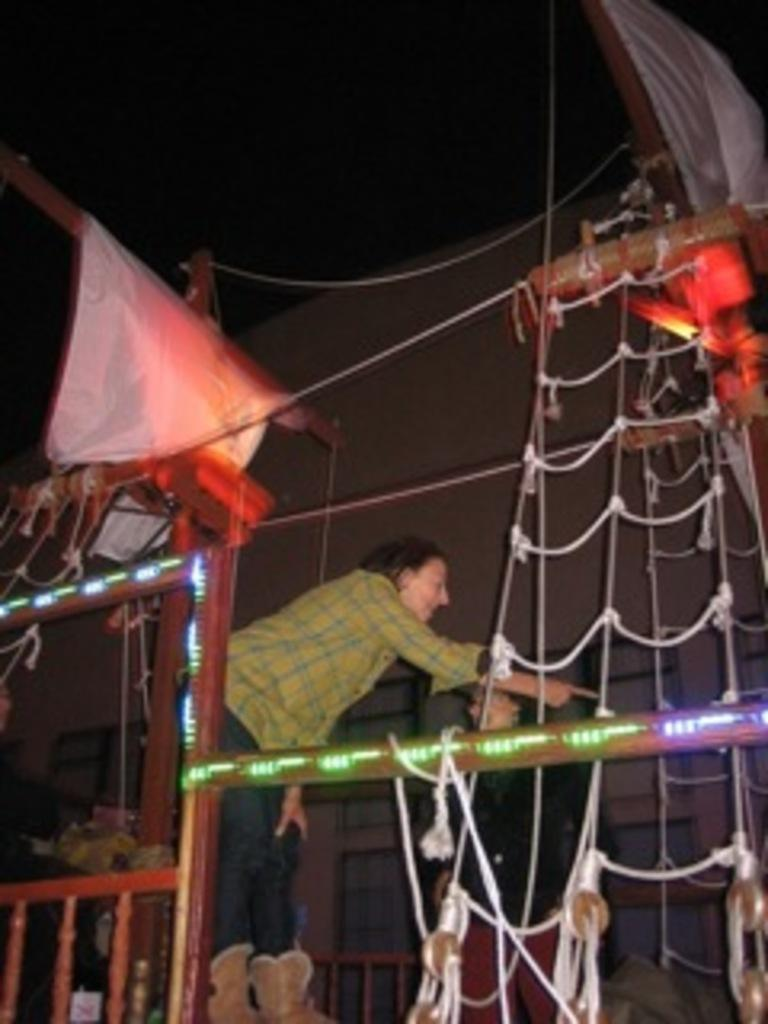Who or what is present in the image? There are people in the image. What objects can be seen in the image that are related to ropes and rods? There are ropes and rods in the image. What items are being hung or supported by the ropes and rods? There are clothes in the image that are being hung or supported by the ropes and rods. What type of structure might the ropes, rods, and railings be part of? The railings, along with the ropes and rods, might be part of a structure like a balcony or clothesline. How many friends are rubbing the clothes in the image? There is no indication in the image that the people are rubbing the clothes, nor is there any mention of friends. 